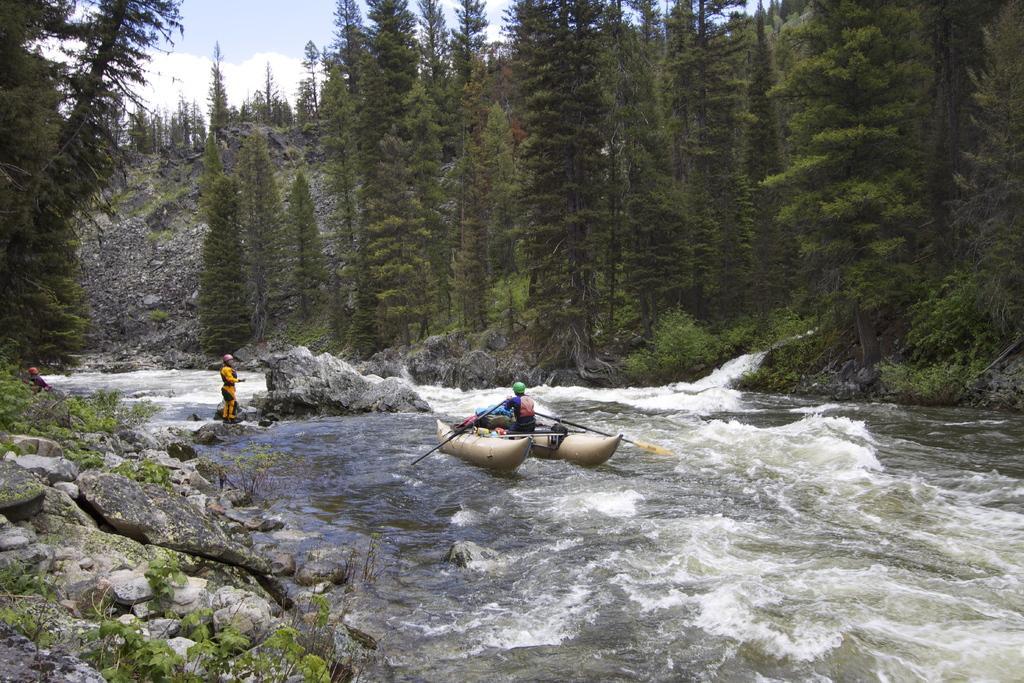Describe this image in one or two sentences. In this image there is one person is on the boat as we can see in middle of this image , and there is a river on the bottom of this image. There is one other person standing on the left side of this image. There are some trees in the background and there are some stones on the bottom left side of this image, and there is a sky on the top of this image. 